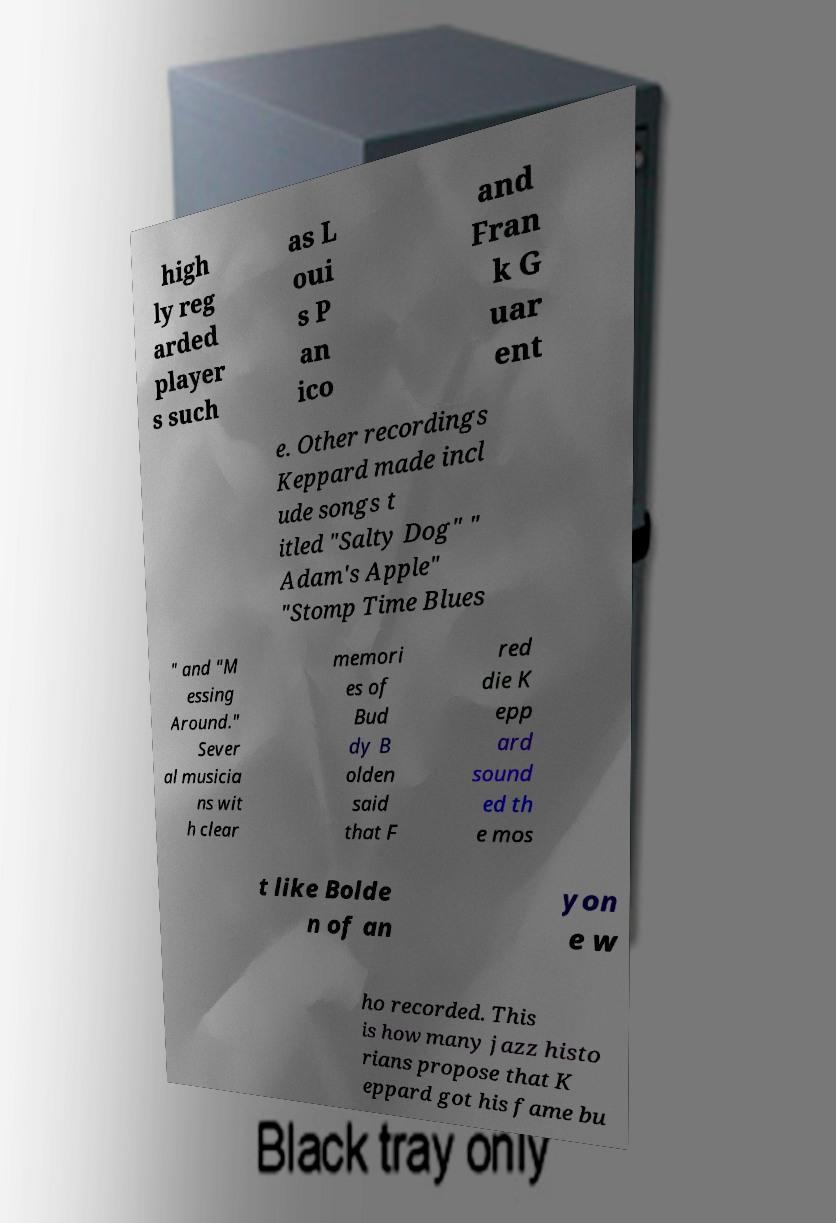Can you accurately transcribe the text from the provided image for me? high ly reg arded player s such as L oui s P an ico and Fran k G uar ent e. Other recordings Keppard made incl ude songs t itled "Salty Dog" " Adam's Apple" "Stomp Time Blues " and "M essing Around." Sever al musicia ns wit h clear memori es of Bud dy B olden said that F red die K epp ard sound ed th e mos t like Bolde n of an yon e w ho recorded. This is how many jazz histo rians propose that K eppard got his fame bu 